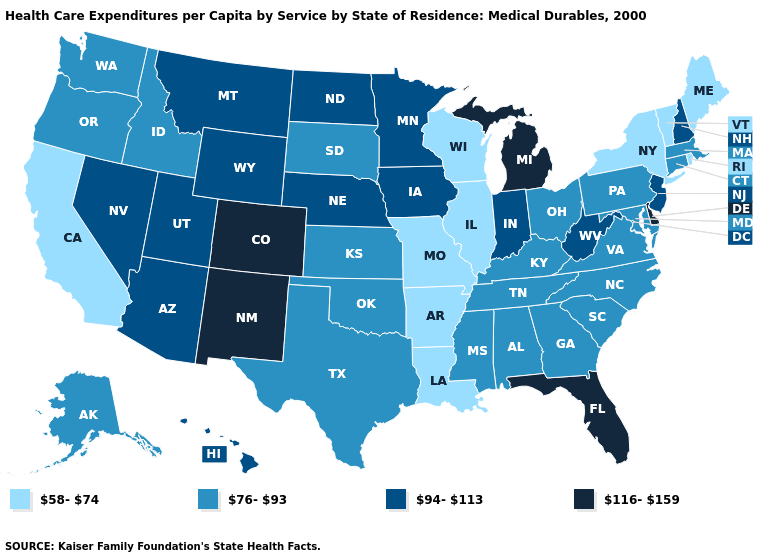Does the map have missing data?
Write a very short answer. No. Which states have the lowest value in the MidWest?
Short answer required. Illinois, Missouri, Wisconsin. Which states have the highest value in the USA?
Be succinct. Colorado, Delaware, Florida, Michigan, New Mexico. Does New York have the same value as Vermont?
Quick response, please. Yes. Among the states that border Alabama , does Mississippi have the lowest value?
Be succinct. Yes. Name the states that have a value in the range 76-93?
Keep it brief. Alabama, Alaska, Connecticut, Georgia, Idaho, Kansas, Kentucky, Maryland, Massachusetts, Mississippi, North Carolina, Ohio, Oklahoma, Oregon, Pennsylvania, South Carolina, South Dakota, Tennessee, Texas, Virginia, Washington. What is the highest value in the USA?
Short answer required. 116-159. What is the lowest value in the West?
Concise answer only. 58-74. What is the highest value in the USA?
Give a very brief answer. 116-159. Name the states that have a value in the range 94-113?
Keep it brief. Arizona, Hawaii, Indiana, Iowa, Minnesota, Montana, Nebraska, Nevada, New Hampshire, New Jersey, North Dakota, Utah, West Virginia, Wyoming. Name the states that have a value in the range 58-74?
Be succinct. Arkansas, California, Illinois, Louisiana, Maine, Missouri, New York, Rhode Island, Vermont, Wisconsin. What is the value of Maine?
Keep it brief. 58-74. What is the lowest value in the South?
Give a very brief answer. 58-74. Name the states that have a value in the range 58-74?
Be succinct. Arkansas, California, Illinois, Louisiana, Maine, Missouri, New York, Rhode Island, Vermont, Wisconsin. What is the highest value in the USA?
Concise answer only. 116-159. 